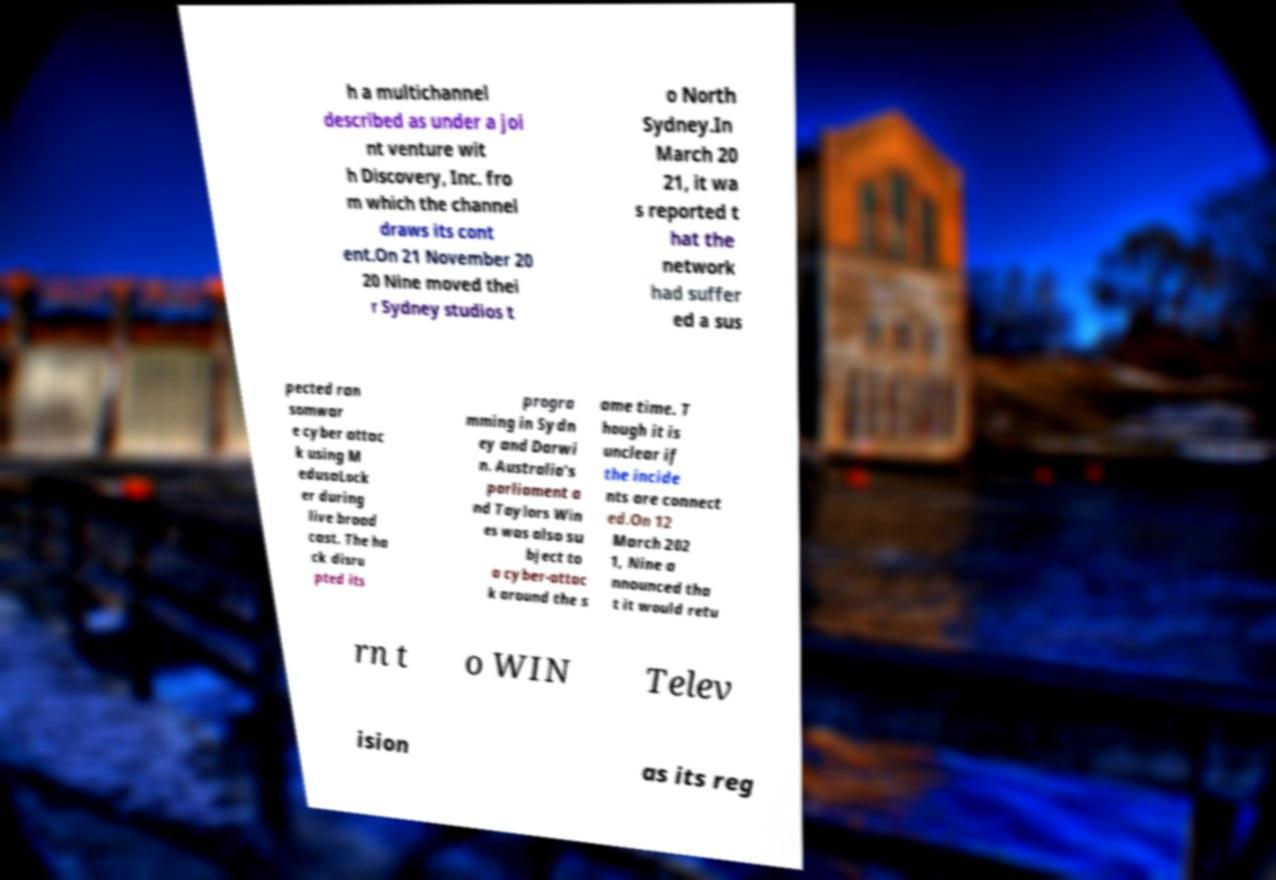What messages or text are displayed in this image? I need them in a readable, typed format. h a multichannel described as under a joi nt venture wit h Discovery, Inc. fro m which the channel draws its cont ent.On 21 November 20 20 Nine moved thei r Sydney studios t o North Sydney.In March 20 21, it wa s reported t hat the network had suffer ed a sus pected ran somwar e cyber attac k using M edusaLock er during live broad cast. The ha ck disru pted its progra mming in Sydn ey and Darwi n. Australia's parliament a nd Taylors Win es was also su bject to a cyber-attac k around the s ame time. T hough it is unclear if the incide nts are connect ed.On 12 March 202 1, Nine a nnounced tha t it would retu rn t o WIN Telev ision as its reg 